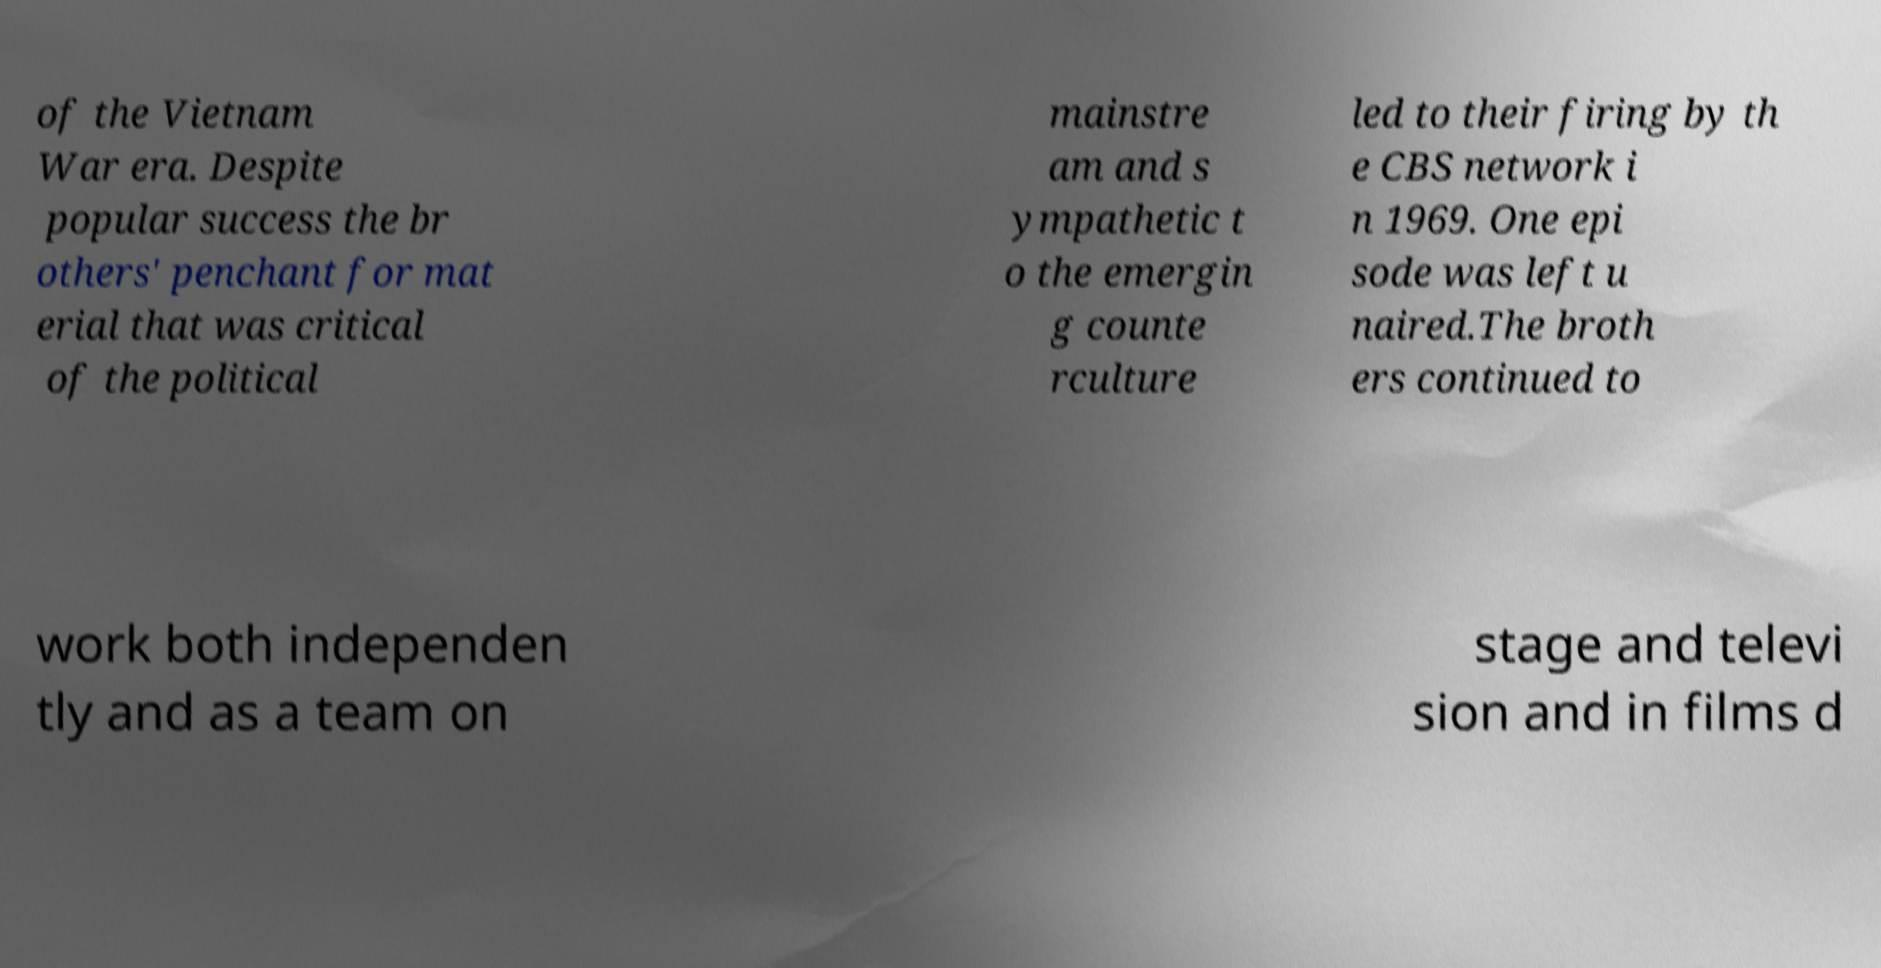Can you accurately transcribe the text from the provided image for me? of the Vietnam War era. Despite popular success the br others' penchant for mat erial that was critical of the political mainstre am and s ympathetic t o the emergin g counte rculture led to their firing by th e CBS network i n 1969. One epi sode was left u naired.The broth ers continued to work both independen tly and as a team on stage and televi sion and in films d 